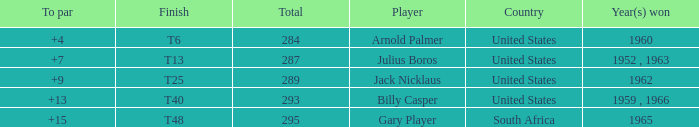What was Gary Player's highest total when his To par was over 15? None. Parse the table in full. {'header': ['To par', 'Finish', 'Total', 'Player', 'Country', 'Year(s) won'], 'rows': [['+4', 'T6', '284', 'Arnold Palmer', 'United States', '1960'], ['+7', 'T13', '287', 'Julius Boros', 'United States', '1952 , 1963'], ['+9', 'T25', '289', 'Jack Nicklaus', 'United States', '1962'], ['+13', 'T40', '293', 'Billy Casper', 'United States', '1959 , 1966'], ['+15', 'T48', '295', 'Gary Player', 'South Africa', '1965']]} 